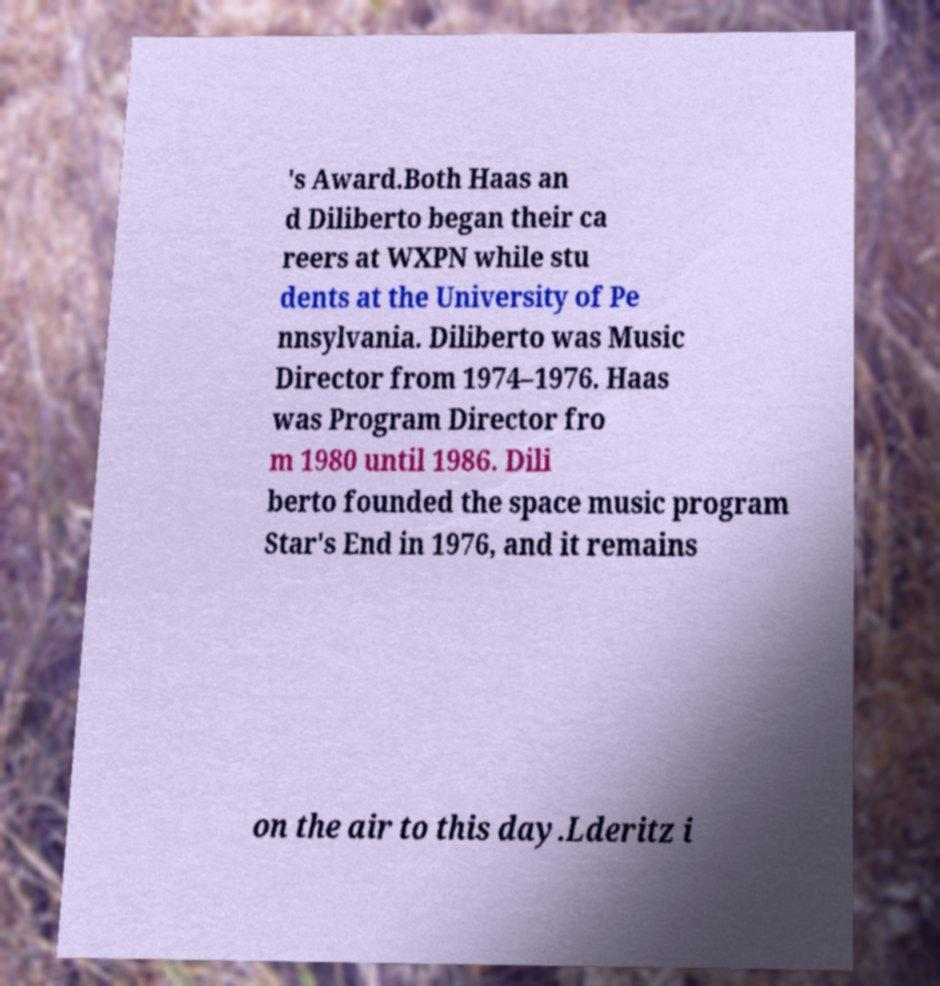I need the written content from this picture converted into text. Can you do that? 's Award.Both Haas an d Diliberto began their ca reers at WXPN while stu dents at the University of Pe nnsylvania. Diliberto was Music Director from 1974–1976. Haas was Program Director fro m 1980 until 1986. Dili berto founded the space music program Star's End in 1976, and it remains on the air to this day.Lderitz i 